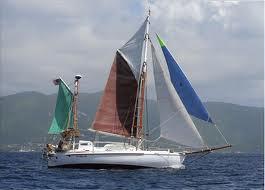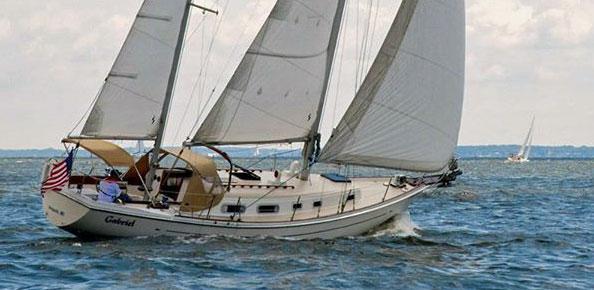The first image is the image on the left, the second image is the image on the right. Given the left and right images, does the statement "All the boats have their sails up." hold true? Answer yes or no. Yes. The first image is the image on the left, the second image is the image on the right. Assess this claim about the two images: "The sails are down on at least one of the vessels.". Correct or not? Answer yes or no. No. 